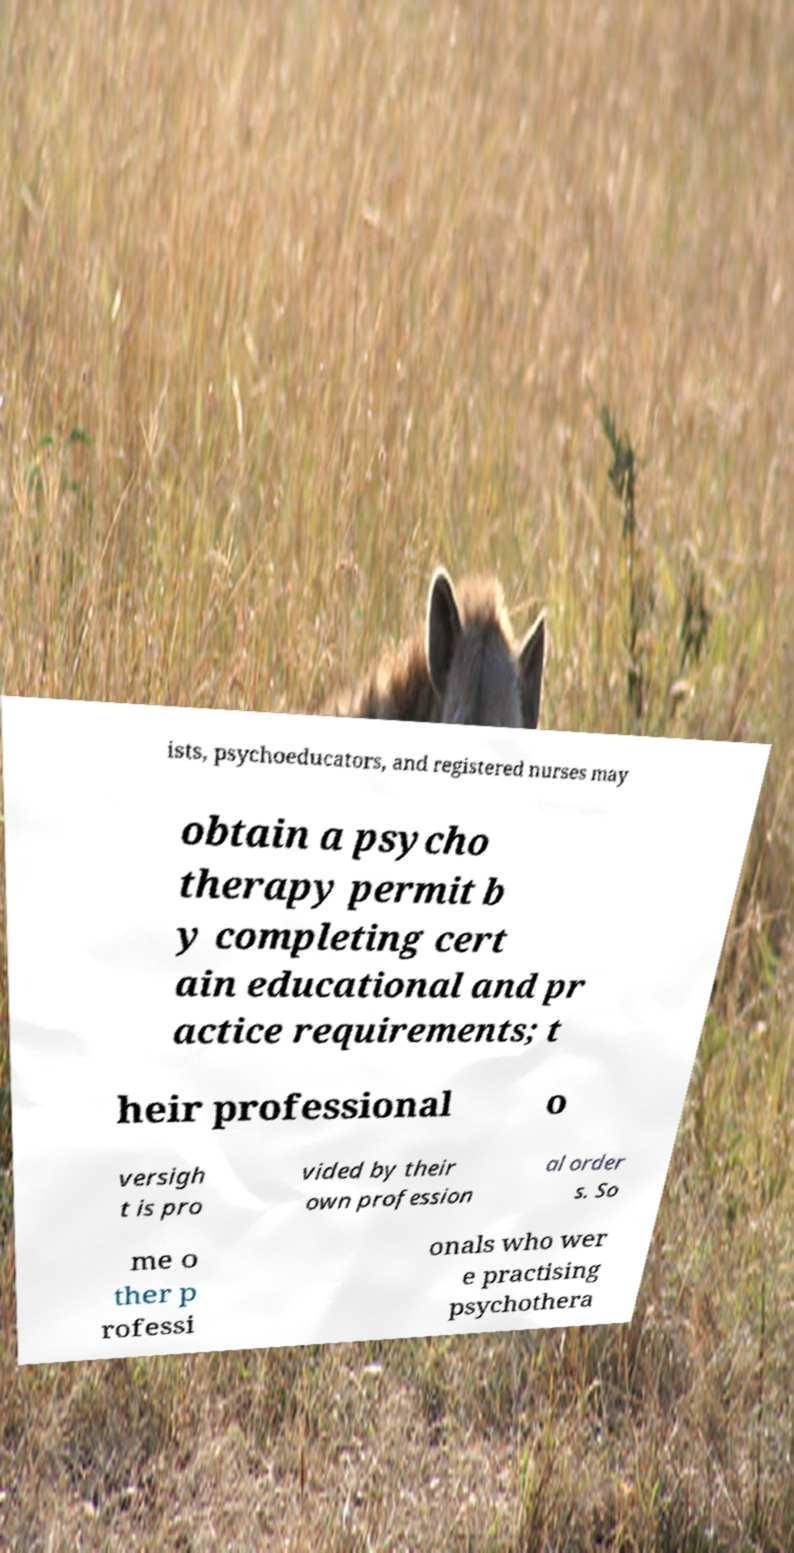There's text embedded in this image that I need extracted. Can you transcribe it verbatim? ists, psychoeducators, and registered nurses may obtain a psycho therapy permit b y completing cert ain educational and pr actice requirements; t heir professional o versigh t is pro vided by their own profession al order s. So me o ther p rofessi onals who wer e practising psychothera 